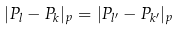<formula> <loc_0><loc_0><loc_500><loc_500>| P _ { l } - P _ { k } | _ { p } = | P _ { l ^ { \prime } } - P _ { k ^ { \prime } } | _ { p }</formula> 